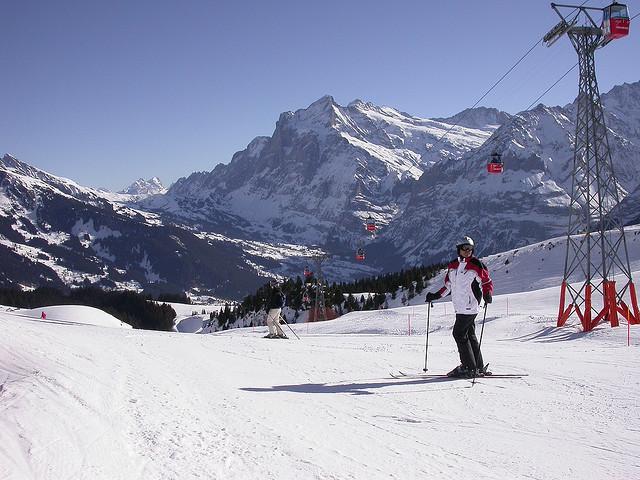Is it daytime?
Answer briefly. Yes. What covers the ground?
Short answer required. Snow. Is the snow deep?
Answer briefly. Yes. 